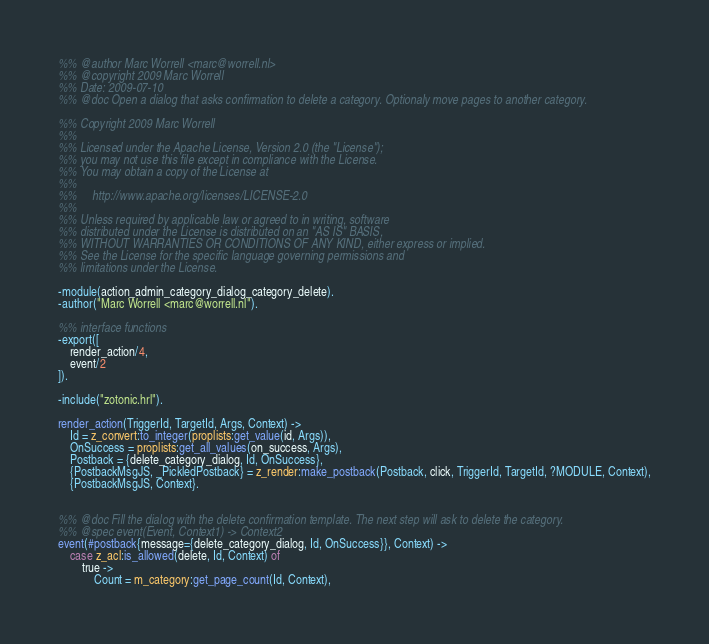Convert code to text. <code><loc_0><loc_0><loc_500><loc_500><_Erlang_>%% @author Marc Worrell <marc@worrell.nl>
%% @copyright 2009 Marc Worrell
%% Date: 2009-07-10
%% @doc Open a dialog that asks confirmation to delete a category. Optionaly move pages to another category.

%% Copyright 2009 Marc Worrell
%%
%% Licensed under the Apache License, Version 2.0 (the "License");
%% you may not use this file except in compliance with the License.
%% You may obtain a copy of the License at
%% 
%%     http://www.apache.org/licenses/LICENSE-2.0
%% 
%% Unless required by applicable law or agreed to in writing, software
%% distributed under the License is distributed on an "AS IS" BASIS,
%% WITHOUT WARRANTIES OR CONDITIONS OF ANY KIND, either express or implied.
%% See the License for the specific language governing permissions and
%% limitations under the License.

-module(action_admin_category_dialog_category_delete).
-author("Marc Worrell <marc@worrell.nl").

%% interface functions
-export([
    render_action/4,
    event/2
]).

-include("zotonic.hrl").

render_action(TriggerId, TargetId, Args, Context) ->
    Id = z_convert:to_integer(proplists:get_value(id, Args)),
    OnSuccess = proplists:get_all_values(on_success, Args),
    Postback = {delete_category_dialog, Id, OnSuccess},
	{PostbackMsgJS, _PickledPostback} = z_render:make_postback(Postback, click, TriggerId, TargetId, ?MODULE, Context),
	{PostbackMsgJS, Context}.


%% @doc Fill the dialog with the delete confirmation template. The next step will ask to delete the category.
%% @spec event(Event, Context1) -> Context2
event(#postback{message={delete_category_dialog, Id, OnSuccess}}, Context) ->
    case z_acl:is_allowed(delete, Id, Context) of
        true ->
            Count = m_category:get_page_count(Id, Context),</code> 